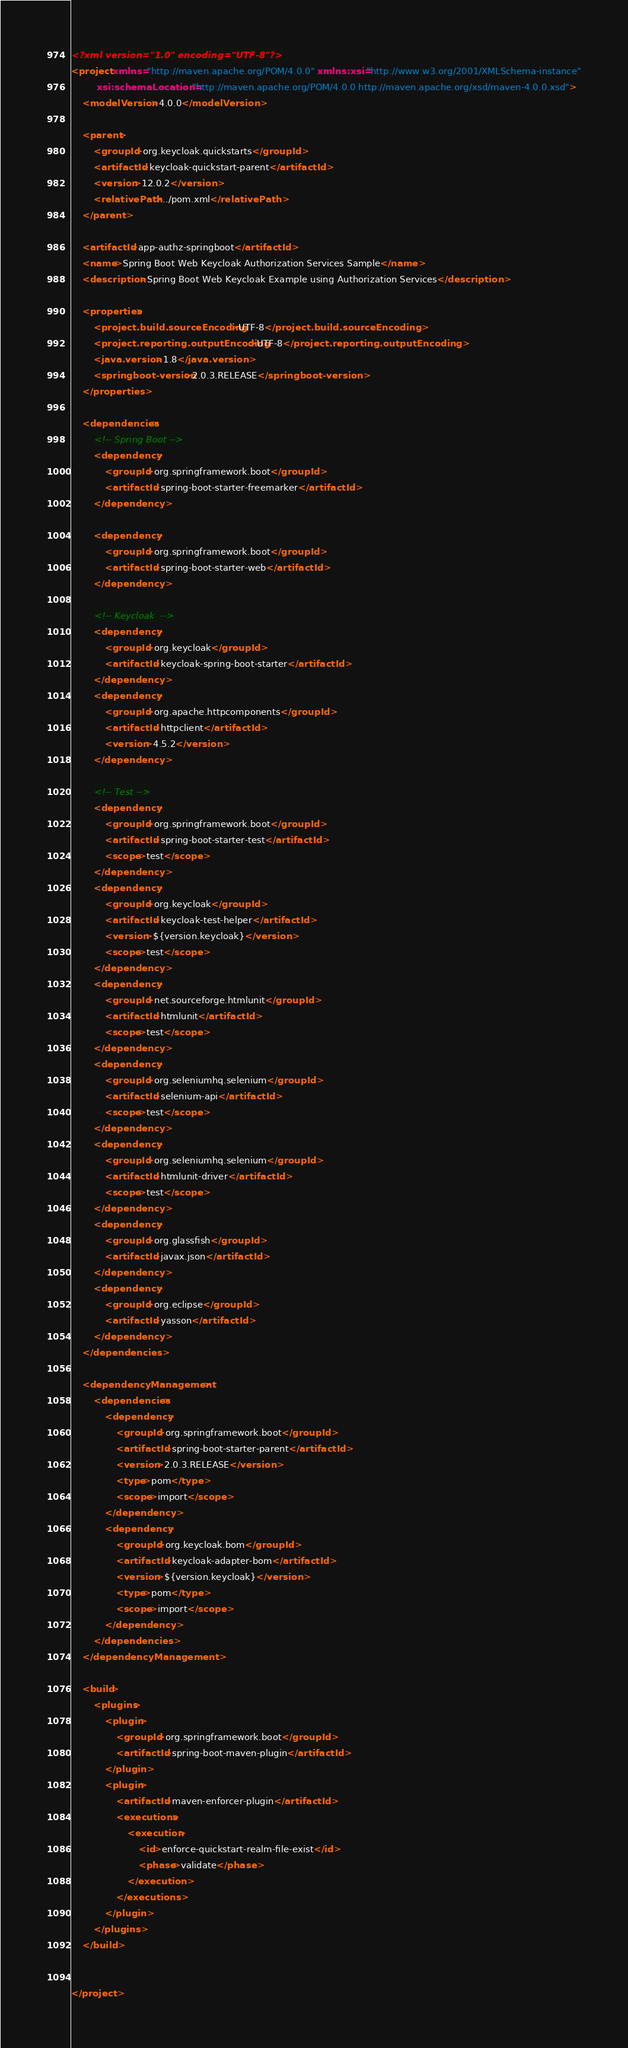<code> <loc_0><loc_0><loc_500><loc_500><_XML_><?xml version="1.0" encoding="UTF-8"?>
<project xmlns="http://maven.apache.org/POM/4.0.0" xmlns:xsi="http://www.w3.org/2001/XMLSchema-instance"
         xsi:schemaLocation="http://maven.apache.org/POM/4.0.0 http://maven.apache.org/xsd/maven-4.0.0.xsd">
    <modelVersion>4.0.0</modelVersion>

    <parent>
        <groupId>org.keycloak.quickstarts</groupId>
        <artifactId>keycloak-quickstart-parent</artifactId>
        <version>12.0.2</version>
        <relativePath>../pom.xml</relativePath>
    </parent>

    <artifactId>app-authz-springboot</artifactId>
    <name>Spring Boot Web Keycloak Authorization Services Sample</name>
    <description>Spring Boot Web Keycloak Example using Authorization Services</description>

    <properties>
        <project.build.sourceEncoding>UTF-8</project.build.sourceEncoding>
        <project.reporting.outputEncoding>UTF-8</project.reporting.outputEncoding>
        <java.version>1.8</java.version>
        <springboot-version>2.0.3.RELEASE</springboot-version>
    </properties>

    <dependencies>
        <!-- Spring Boot -->
        <dependency>
            <groupId>org.springframework.boot</groupId>
            <artifactId>spring-boot-starter-freemarker</artifactId>
        </dependency>

        <dependency>
            <groupId>org.springframework.boot</groupId>
            <artifactId>spring-boot-starter-web</artifactId>
        </dependency>

        <!-- Keycloak  -->
        <dependency>
            <groupId>org.keycloak</groupId>
            <artifactId>keycloak-spring-boot-starter</artifactId>
        </dependency>
        <dependency>
            <groupId>org.apache.httpcomponents</groupId>
            <artifactId>httpclient</artifactId>
            <version>4.5.2</version>
        </dependency>

        <!-- Test -->
        <dependency>
            <groupId>org.springframework.boot</groupId>
            <artifactId>spring-boot-starter-test</artifactId>
            <scope>test</scope>
        </dependency>
        <dependency>
            <groupId>org.keycloak</groupId>
            <artifactId>keycloak-test-helper</artifactId>
            <version>${version.keycloak}</version>
            <scope>test</scope>
        </dependency>
        <dependency>
            <groupId>net.sourceforge.htmlunit</groupId>
            <artifactId>htmlunit</artifactId>
            <scope>test</scope>
        </dependency>
        <dependency>
            <groupId>org.seleniumhq.selenium</groupId>
            <artifactId>selenium-api</artifactId>
            <scope>test</scope>
        </dependency>
        <dependency>
            <groupId>org.seleniumhq.selenium</groupId>
            <artifactId>htmlunit-driver</artifactId>
            <scope>test</scope>
        </dependency>
        <dependency>
            <groupId>org.glassfish</groupId>
            <artifactId>javax.json</artifactId>
        </dependency>
        <dependency>
            <groupId>org.eclipse</groupId>
            <artifactId>yasson</artifactId>
        </dependency>
    </dependencies>

    <dependencyManagement>
        <dependencies>
            <dependency>
                <groupId>org.springframework.boot</groupId>
                <artifactId>spring-boot-starter-parent</artifactId>
                <version>2.0.3.RELEASE</version>
                <type>pom</type>
                <scope>import</scope>
            </dependency>
            <dependency>
                <groupId>org.keycloak.bom</groupId>
                <artifactId>keycloak-adapter-bom</artifactId>
                <version>${version.keycloak}</version>
                <type>pom</type>
                <scope>import</scope>
            </dependency>
        </dependencies>
    </dependencyManagement>

    <build>
        <plugins>
            <plugin>
                <groupId>org.springframework.boot</groupId>
                <artifactId>spring-boot-maven-plugin</artifactId>
            </plugin>
            <plugin>
                <artifactId>maven-enforcer-plugin</artifactId>
                <executions>
                    <execution>
                        <id>enforce-quickstart-realm-file-exist</id>
                        <phase>validate</phase>
                    </execution>
                </executions>
            </plugin>
        </plugins>
    </build>


</project>
</code> 